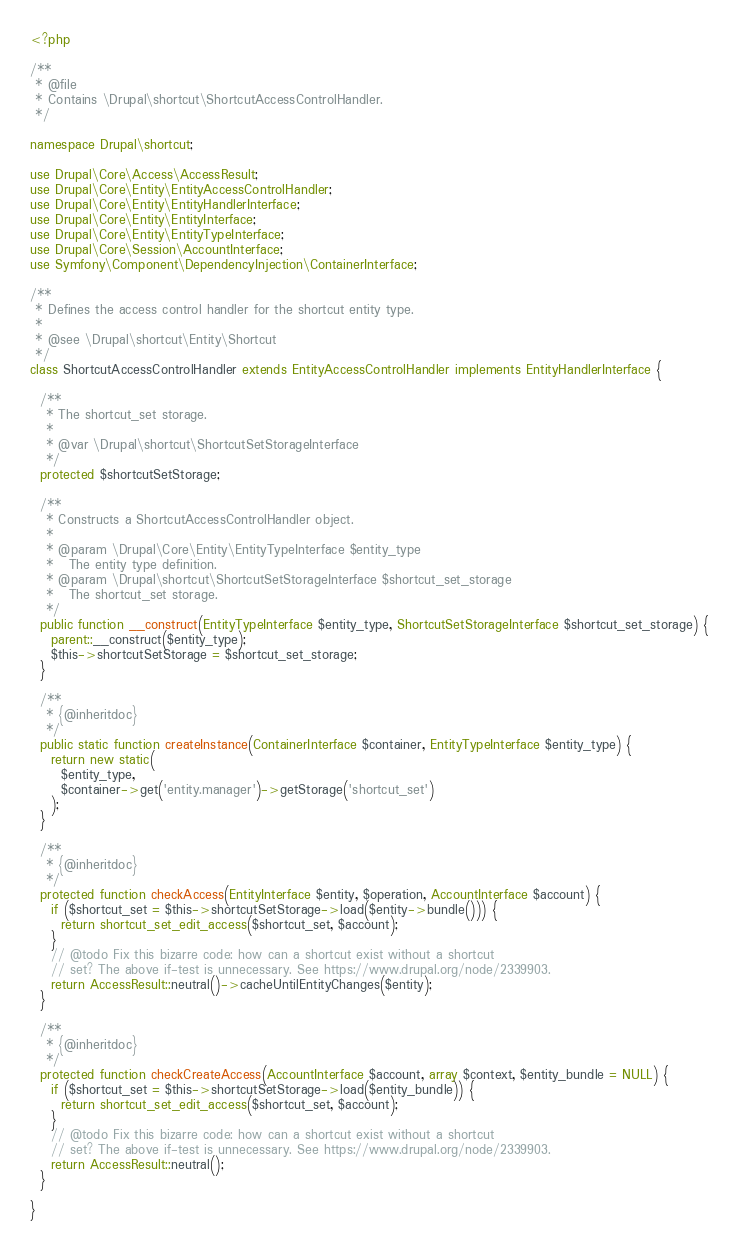<code> <loc_0><loc_0><loc_500><loc_500><_PHP_><?php

/**
 * @file
 * Contains \Drupal\shortcut\ShortcutAccessControlHandler.
 */

namespace Drupal\shortcut;

use Drupal\Core\Access\AccessResult;
use Drupal\Core\Entity\EntityAccessControlHandler;
use Drupal\Core\Entity\EntityHandlerInterface;
use Drupal\Core\Entity\EntityInterface;
use Drupal\Core\Entity\EntityTypeInterface;
use Drupal\Core\Session\AccountInterface;
use Symfony\Component\DependencyInjection\ContainerInterface;

/**
 * Defines the access control handler for the shortcut entity type.
 *
 * @see \Drupal\shortcut\Entity\Shortcut
 */
class ShortcutAccessControlHandler extends EntityAccessControlHandler implements EntityHandlerInterface {

  /**
   * The shortcut_set storage.
   *
   * @var \Drupal\shortcut\ShortcutSetStorageInterface
   */
  protected $shortcutSetStorage;

  /**
   * Constructs a ShortcutAccessControlHandler object.
   *
   * @param \Drupal\Core\Entity\EntityTypeInterface $entity_type
   *   The entity type definition.
   * @param \Drupal\shortcut\ShortcutSetStorageInterface $shortcut_set_storage
   *   The shortcut_set storage.
   */
  public function __construct(EntityTypeInterface $entity_type, ShortcutSetStorageInterface $shortcut_set_storage) {
    parent::__construct($entity_type);
    $this->shortcutSetStorage = $shortcut_set_storage;
  }

  /**
   * {@inheritdoc}
   */
  public static function createInstance(ContainerInterface $container, EntityTypeInterface $entity_type) {
    return new static(
      $entity_type,
      $container->get('entity.manager')->getStorage('shortcut_set')
    );
  }

  /**
   * {@inheritdoc}
   */
  protected function checkAccess(EntityInterface $entity, $operation, AccountInterface $account) {
    if ($shortcut_set = $this->shortcutSetStorage->load($entity->bundle())) {
      return shortcut_set_edit_access($shortcut_set, $account);
    }
    // @todo Fix this bizarre code: how can a shortcut exist without a shortcut
    // set? The above if-test is unnecessary. See https://www.drupal.org/node/2339903.
    return AccessResult::neutral()->cacheUntilEntityChanges($entity);
  }

  /**
   * {@inheritdoc}
   */
  protected function checkCreateAccess(AccountInterface $account, array $context, $entity_bundle = NULL) {
    if ($shortcut_set = $this->shortcutSetStorage->load($entity_bundle)) {
      return shortcut_set_edit_access($shortcut_set, $account);
    }
    // @todo Fix this bizarre code: how can a shortcut exist without a shortcut
    // set? The above if-test is unnecessary. See https://www.drupal.org/node/2339903.
    return AccessResult::neutral();
  }

}
</code> 